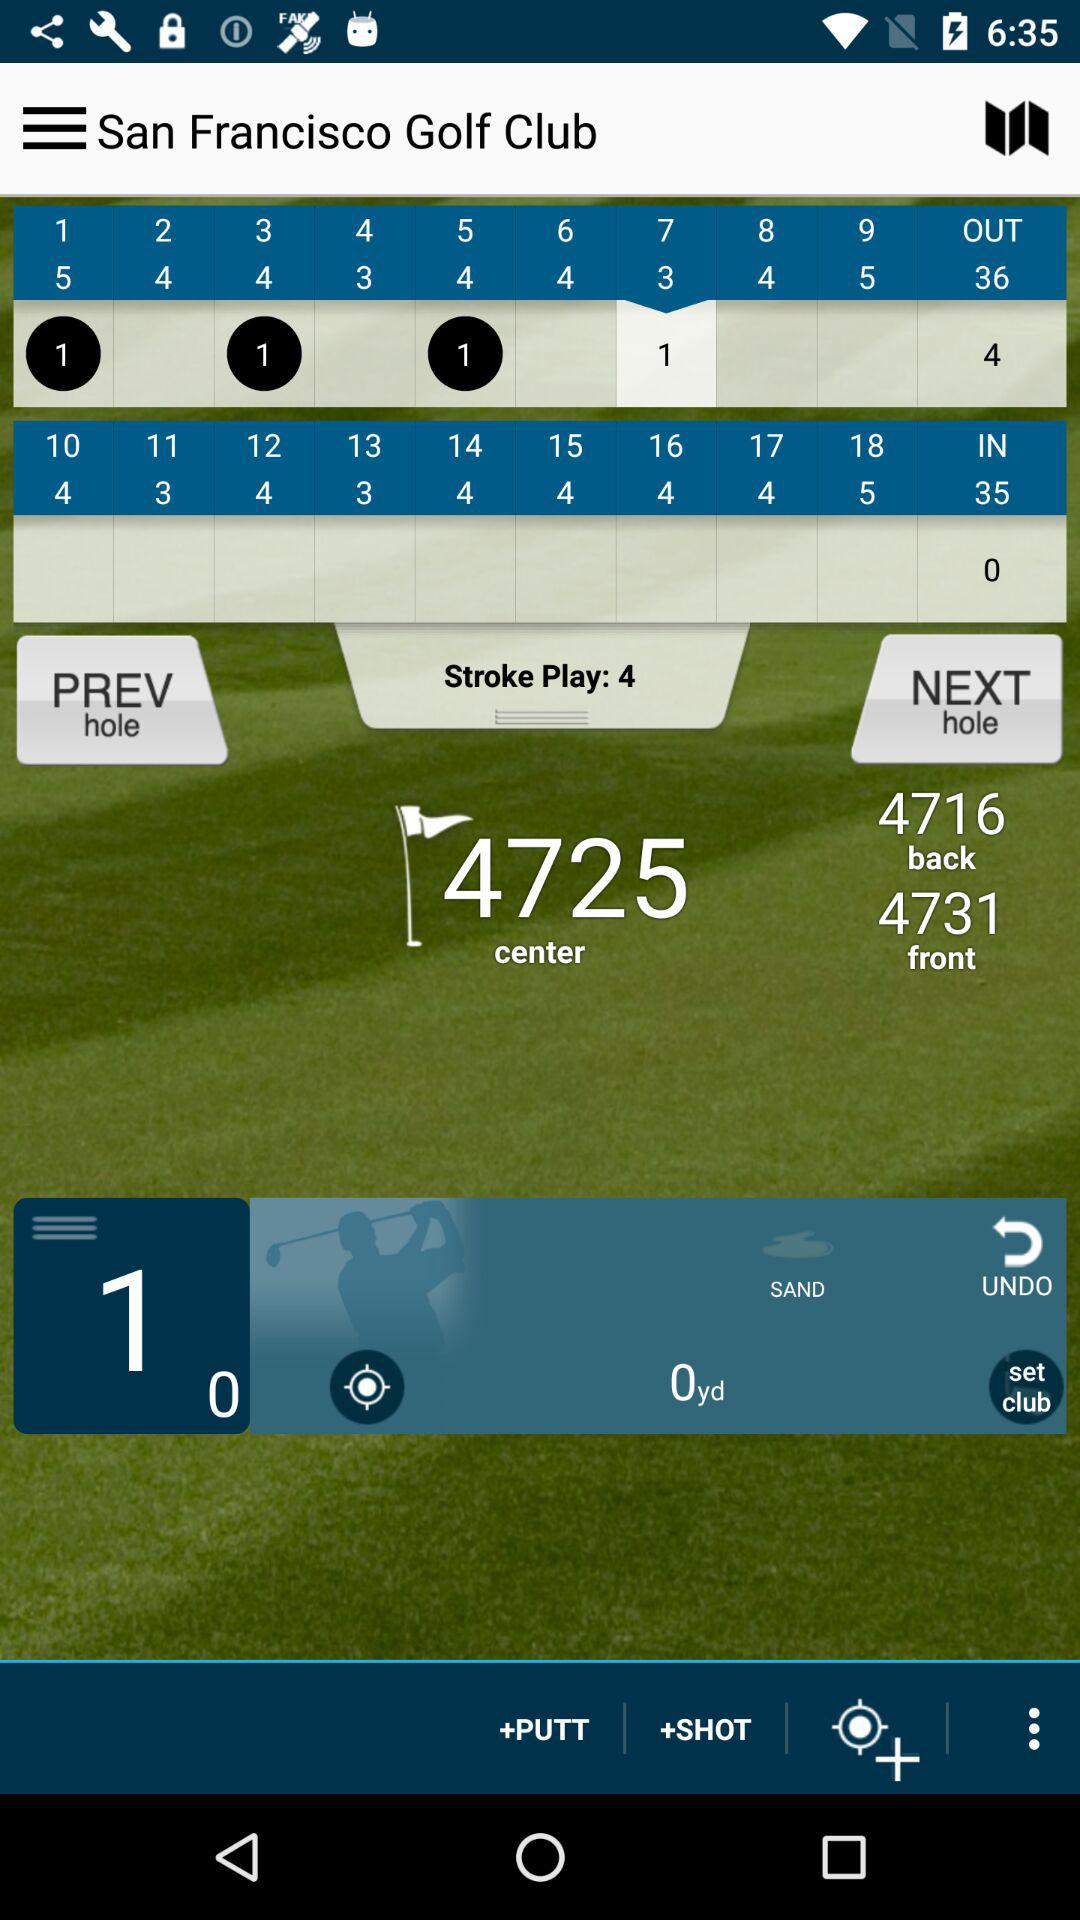What is the version number?
When the provided information is insufficient, respond with <no answer>. <no answer> 